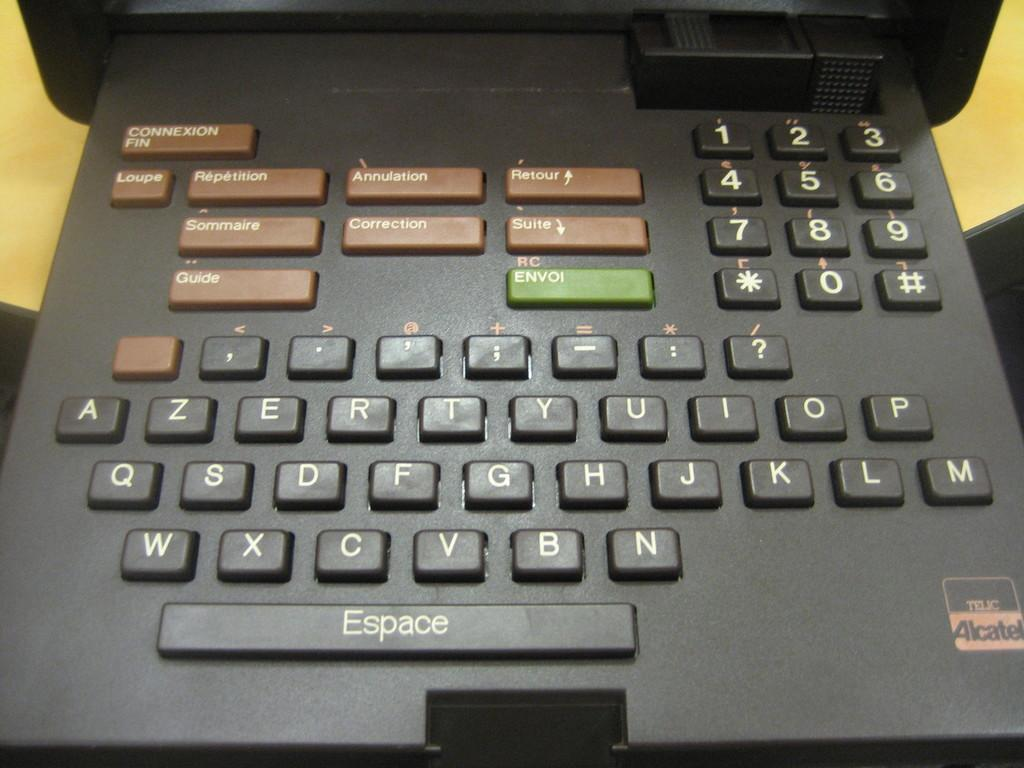<image>
Offer a succinct explanation of the picture presented. A very old looking keyboard contraption with an "Espace" key. 